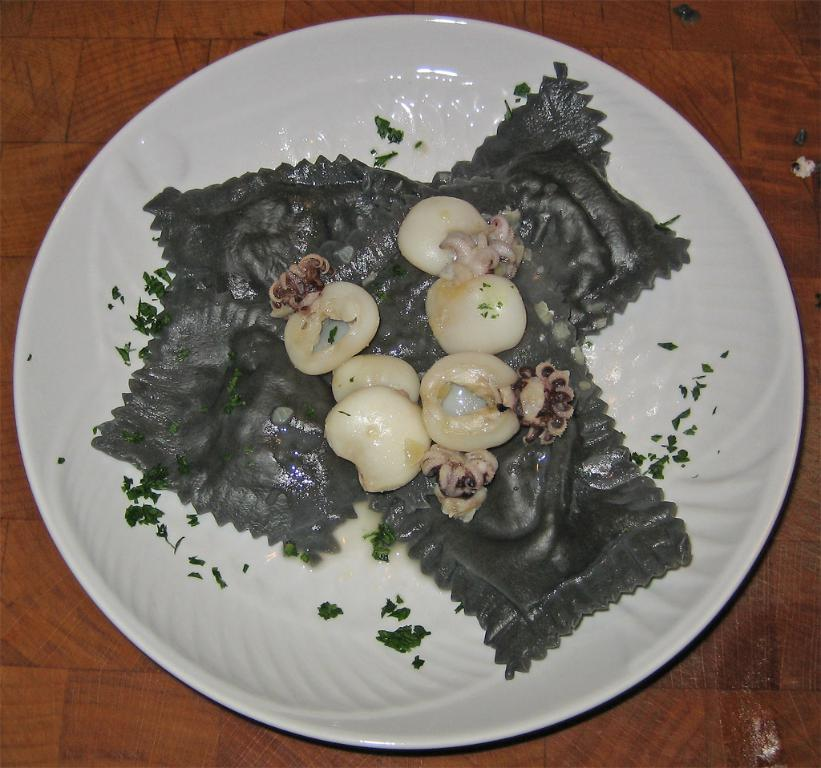What is present on the plate in the image? There are food items on the plate in the image. Where is the plate located? The plate is on a platform. How many snakes are slithering around the food items on the plate? There are no snakes present in the image; the plate contains only food items. What level of respect can be observed in the image? The image does not depict any people or actions, so it is not possible to determine the level of respect. 